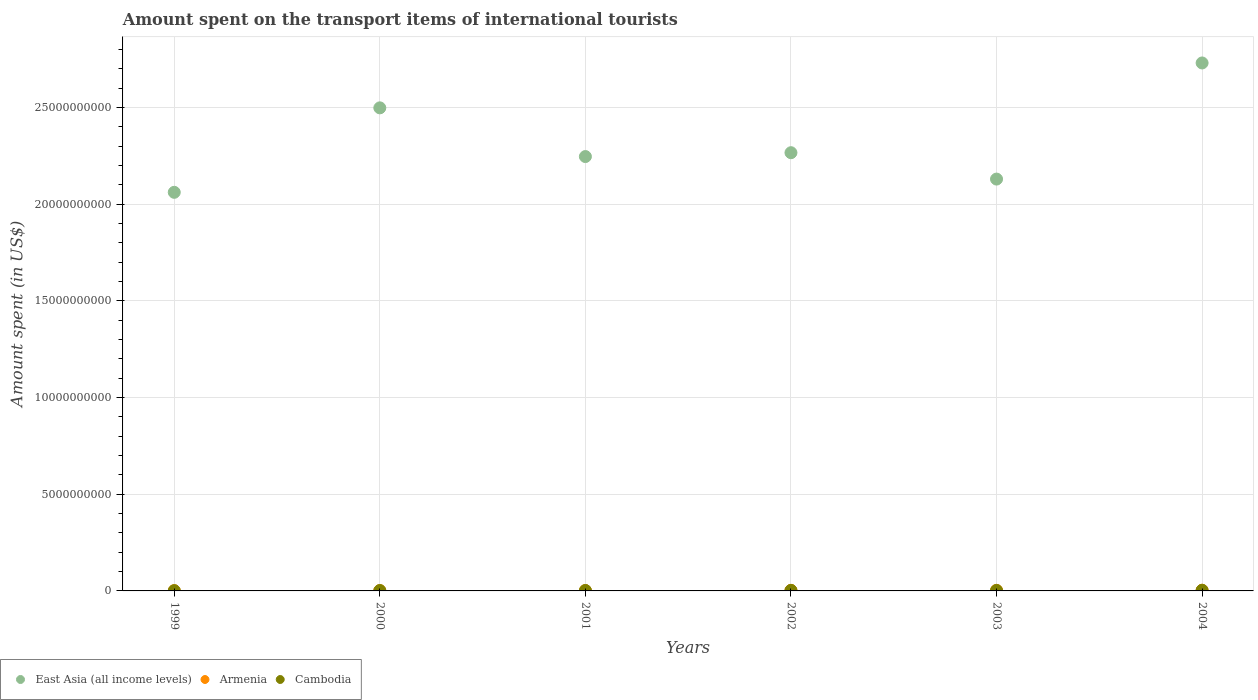Is the number of dotlines equal to the number of legend labels?
Offer a terse response. Yes. What is the amount spent on the transport items of international tourists in East Asia (all income levels) in 1999?
Offer a very short reply. 2.06e+1. Across all years, what is the maximum amount spent on the transport items of international tourists in Armenia?
Provide a succinct answer. 3.70e+07. Across all years, what is the minimum amount spent on the transport items of international tourists in East Asia (all income levels)?
Give a very brief answer. 2.06e+1. In which year was the amount spent on the transport items of international tourists in Cambodia maximum?
Provide a succinct answer. 2004. In which year was the amount spent on the transport items of international tourists in East Asia (all income levels) minimum?
Ensure brevity in your answer.  1999. What is the total amount spent on the transport items of international tourists in East Asia (all income levels) in the graph?
Your answer should be very brief. 1.39e+11. What is the difference between the amount spent on the transport items of international tourists in Cambodia in 1999 and that in 2002?
Offer a very short reply. -1.30e+07. What is the difference between the amount spent on the transport items of international tourists in Cambodia in 2002 and the amount spent on the transport items of international tourists in Armenia in 2000?
Your answer should be very brief. 1.00e+07. What is the average amount spent on the transport items of international tourists in East Asia (all income levels) per year?
Keep it short and to the point. 2.32e+1. In the year 2001, what is the difference between the amount spent on the transport items of international tourists in Cambodia and amount spent on the transport items of international tourists in East Asia (all income levels)?
Give a very brief answer. -2.24e+1. In how many years, is the amount spent on the transport items of international tourists in Cambodia greater than 19000000000 US$?
Your answer should be compact. 0. What is the ratio of the amount spent on the transport items of international tourists in East Asia (all income levels) in 2000 to that in 2001?
Make the answer very short. 1.11. Is the difference between the amount spent on the transport items of international tourists in Cambodia in 1999 and 2004 greater than the difference between the amount spent on the transport items of international tourists in East Asia (all income levels) in 1999 and 2004?
Your answer should be compact. Yes. What is the difference between the highest and the lowest amount spent on the transport items of international tourists in Cambodia?
Make the answer very short. 1.90e+07. In how many years, is the amount spent on the transport items of international tourists in Cambodia greater than the average amount spent on the transport items of international tourists in Cambodia taken over all years?
Your answer should be very brief. 3. Is the amount spent on the transport items of international tourists in Cambodia strictly less than the amount spent on the transport items of international tourists in East Asia (all income levels) over the years?
Provide a short and direct response. Yes. How many years are there in the graph?
Your response must be concise. 6. Are the values on the major ticks of Y-axis written in scientific E-notation?
Give a very brief answer. No. Does the graph contain any zero values?
Provide a short and direct response. No. How many legend labels are there?
Provide a short and direct response. 3. How are the legend labels stacked?
Give a very brief answer. Horizontal. What is the title of the graph?
Offer a very short reply. Amount spent on the transport items of international tourists. Does "Bosnia and Herzegovina" appear as one of the legend labels in the graph?
Give a very brief answer. No. What is the label or title of the X-axis?
Provide a short and direct response. Years. What is the label or title of the Y-axis?
Give a very brief answer. Amount spent (in US$). What is the Amount spent (in US$) of East Asia (all income levels) in 1999?
Keep it short and to the point. 2.06e+1. What is the Amount spent (in US$) of Armenia in 1999?
Your answer should be compact. 1.40e+07. What is the Amount spent (in US$) in Cambodia in 1999?
Offer a very short reply. 1.30e+07. What is the Amount spent (in US$) of East Asia (all income levels) in 2000?
Ensure brevity in your answer.  2.50e+1. What is the Amount spent (in US$) of Armenia in 2000?
Your answer should be compact. 1.60e+07. What is the Amount spent (in US$) in Cambodia in 2000?
Offer a terse response. 1.90e+07. What is the Amount spent (in US$) in East Asia (all income levels) in 2001?
Your answer should be compact. 2.25e+1. What is the Amount spent (in US$) in Armenia in 2001?
Keep it short and to the point. 1.90e+07. What is the Amount spent (in US$) of Cambodia in 2001?
Your response must be concise. 2.20e+07. What is the Amount spent (in US$) of East Asia (all income levels) in 2002?
Offer a terse response. 2.27e+1. What is the Amount spent (in US$) in Armenia in 2002?
Ensure brevity in your answer.  3.10e+07. What is the Amount spent (in US$) in Cambodia in 2002?
Offer a terse response. 2.60e+07. What is the Amount spent (in US$) in East Asia (all income levels) in 2003?
Provide a short and direct response. 2.13e+1. What is the Amount spent (in US$) in Armenia in 2003?
Offer a very short reply. 3.00e+07. What is the Amount spent (in US$) of Cambodia in 2003?
Your answer should be compact. 2.40e+07. What is the Amount spent (in US$) of East Asia (all income levels) in 2004?
Offer a very short reply. 2.73e+1. What is the Amount spent (in US$) in Armenia in 2004?
Make the answer very short. 3.70e+07. What is the Amount spent (in US$) of Cambodia in 2004?
Give a very brief answer. 3.20e+07. Across all years, what is the maximum Amount spent (in US$) of East Asia (all income levels)?
Keep it short and to the point. 2.73e+1. Across all years, what is the maximum Amount spent (in US$) in Armenia?
Your answer should be very brief. 3.70e+07. Across all years, what is the maximum Amount spent (in US$) of Cambodia?
Ensure brevity in your answer.  3.20e+07. Across all years, what is the minimum Amount spent (in US$) in East Asia (all income levels)?
Ensure brevity in your answer.  2.06e+1. Across all years, what is the minimum Amount spent (in US$) of Armenia?
Your answer should be compact. 1.40e+07. Across all years, what is the minimum Amount spent (in US$) of Cambodia?
Make the answer very short. 1.30e+07. What is the total Amount spent (in US$) of East Asia (all income levels) in the graph?
Give a very brief answer. 1.39e+11. What is the total Amount spent (in US$) in Armenia in the graph?
Offer a terse response. 1.47e+08. What is the total Amount spent (in US$) in Cambodia in the graph?
Ensure brevity in your answer.  1.36e+08. What is the difference between the Amount spent (in US$) of East Asia (all income levels) in 1999 and that in 2000?
Give a very brief answer. -4.37e+09. What is the difference between the Amount spent (in US$) of Cambodia in 1999 and that in 2000?
Keep it short and to the point. -6.00e+06. What is the difference between the Amount spent (in US$) of East Asia (all income levels) in 1999 and that in 2001?
Offer a very short reply. -1.85e+09. What is the difference between the Amount spent (in US$) in Armenia in 1999 and that in 2001?
Give a very brief answer. -5.00e+06. What is the difference between the Amount spent (in US$) in Cambodia in 1999 and that in 2001?
Provide a succinct answer. -9.00e+06. What is the difference between the Amount spent (in US$) of East Asia (all income levels) in 1999 and that in 2002?
Provide a succinct answer. -2.05e+09. What is the difference between the Amount spent (in US$) of Armenia in 1999 and that in 2002?
Your answer should be compact. -1.70e+07. What is the difference between the Amount spent (in US$) in Cambodia in 1999 and that in 2002?
Provide a short and direct response. -1.30e+07. What is the difference between the Amount spent (in US$) of East Asia (all income levels) in 1999 and that in 2003?
Ensure brevity in your answer.  -6.85e+08. What is the difference between the Amount spent (in US$) of Armenia in 1999 and that in 2003?
Your answer should be compact. -1.60e+07. What is the difference between the Amount spent (in US$) in Cambodia in 1999 and that in 2003?
Your answer should be compact. -1.10e+07. What is the difference between the Amount spent (in US$) in East Asia (all income levels) in 1999 and that in 2004?
Your response must be concise. -6.69e+09. What is the difference between the Amount spent (in US$) of Armenia in 1999 and that in 2004?
Your answer should be compact. -2.30e+07. What is the difference between the Amount spent (in US$) in Cambodia in 1999 and that in 2004?
Make the answer very short. -1.90e+07. What is the difference between the Amount spent (in US$) in East Asia (all income levels) in 2000 and that in 2001?
Ensure brevity in your answer.  2.52e+09. What is the difference between the Amount spent (in US$) in Armenia in 2000 and that in 2001?
Your answer should be very brief. -3.00e+06. What is the difference between the Amount spent (in US$) in East Asia (all income levels) in 2000 and that in 2002?
Offer a very short reply. 2.32e+09. What is the difference between the Amount spent (in US$) of Armenia in 2000 and that in 2002?
Offer a very short reply. -1.50e+07. What is the difference between the Amount spent (in US$) in Cambodia in 2000 and that in 2002?
Your answer should be very brief. -7.00e+06. What is the difference between the Amount spent (in US$) of East Asia (all income levels) in 2000 and that in 2003?
Give a very brief answer. 3.68e+09. What is the difference between the Amount spent (in US$) of Armenia in 2000 and that in 2003?
Your response must be concise. -1.40e+07. What is the difference between the Amount spent (in US$) in Cambodia in 2000 and that in 2003?
Make the answer very short. -5.00e+06. What is the difference between the Amount spent (in US$) in East Asia (all income levels) in 2000 and that in 2004?
Make the answer very short. -2.32e+09. What is the difference between the Amount spent (in US$) in Armenia in 2000 and that in 2004?
Offer a terse response. -2.10e+07. What is the difference between the Amount spent (in US$) of Cambodia in 2000 and that in 2004?
Offer a very short reply. -1.30e+07. What is the difference between the Amount spent (in US$) in East Asia (all income levels) in 2001 and that in 2002?
Make the answer very short. -2.00e+08. What is the difference between the Amount spent (in US$) of Armenia in 2001 and that in 2002?
Offer a very short reply. -1.20e+07. What is the difference between the Amount spent (in US$) in East Asia (all income levels) in 2001 and that in 2003?
Provide a succinct answer. 1.16e+09. What is the difference between the Amount spent (in US$) in Armenia in 2001 and that in 2003?
Ensure brevity in your answer.  -1.10e+07. What is the difference between the Amount spent (in US$) of Cambodia in 2001 and that in 2003?
Ensure brevity in your answer.  -2.00e+06. What is the difference between the Amount spent (in US$) of East Asia (all income levels) in 2001 and that in 2004?
Keep it short and to the point. -4.84e+09. What is the difference between the Amount spent (in US$) in Armenia in 2001 and that in 2004?
Your response must be concise. -1.80e+07. What is the difference between the Amount spent (in US$) in Cambodia in 2001 and that in 2004?
Make the answer very short. -1.00e+07. What is the difference between the Amount spent (in US$) in East Asia (all income levels) in 2002 and that in 2003?
Provide a short and direct response. 1.36e+09. What is the difference between the Amount spent (in US$) of Armenia in 2002 and that in 2003?
Keep it short and to the point. 1.00e+06. What is the difference between the Amount spent (in US$) of East Asia (all income levels) in 2002 and that in 2004?
Provide a succinct answer. -4.64e+09. What is the difference between the Amount spent (in US$) in Armenia in 2002 and that in 2004?
Provide a succinct answer. -6.00e+06. What is the difference between the Amount spent (in US$) in Cambodia in 2002 and that in 2004?
Provide a succinct answer. -6.00e+06. What is the difference between the Amount spent (in US$) in East Asia (all income levels) in 2003 and that in 2004?
Make the answer very short. -6.01e+09. What is the difference between the Amount spent (in US$) in Armenia in 2003 and that in 2004?
Give a very brief answer. -7.00e+06. What is the difference between the Amount spent (in US$) of Cambodia in 2003 and that in 2004?
Offer a terse response. -8.00e+06. What is the difference between the Amount spent (in US$) in East Asia (all income levels) in 1999 and the Amount spent (in US$) in Armenia in 2000?
Provide a succinct answer. 2.06e+1. What is the difference between the Amount spent (in US$) in East Asia (all income levels) in 1999 and the Amount spent (in US$) in Cambodia in 2000?
Make the answer very short. 2.06e+1. What is the difference between the Amount spent (in US$) in Armenia in 1999 and the Amount spent (in US$) in Cambodia in 2000?
Keep it short and to the point. -5.00e+06. What is the difference between the Amount spent (in US$) in East Asia (all income levels) in 1999 and the Amount spent (in US$) in Armenia in 2001?
Keep it short and to the point. 2.06e+1. What is the difference between the Amount spent (in US$) in East Asia (all income levels) in 1999 and the Amount spent (in US$) in Cambodia in 2001?
Keep it short and to the point. 2.06e+1. What is the difference between the Amount spent (in US$) in Armenia in 1999 and the Amount spent (in US$) in Cambodia in 2001?
Offer a very short reply. -8.00e+06. What is the difference between the Amount spent (in US$) of East Asia (all income levels) in 1999 and the Amount spent (in US$) of Armenia in 2002?
Make the answer very short. 2.06e+1. What is the difference between the Amount spent (in US$) in East Asia (all income levels) in 1999 and the Amount spent (in US$) in Cambodia in 2002?
Keep it short and to the point. 2.06e+1. What is the difference between the Amount spent (in US$) in Armenia in 1999 and the Amount spent (in US$) in Cambodia in 2002?
Ensure brevity in your answer.  -1.20e+07. What is the difference between the Amount spent (in US$) in East Asia (all income levels) in 1999 and the Amount spent (in US$) in Armenia in 2003?
Keep it short and to the point. 2.06e+1. What is the difference between the Amount spent (in US$) of East Asia (all income levels) in 1999 and the Amount spent (in US$) of Cambodia in 2003?
Your response must be concise. 2.06e+1. What is the difference between the Amount spent (in US$) of Armenia in 1999 and the Amount spent (in US$) of Cambodia in 2003?
Give a very brief answer. -1.00e+07. What is the difference between the Amount spent (in US$) of East Asia (all income levels) in 1999 and the Amount spent (in US$) of Armenia in 2004?
Your response must be concise. 2.06e+1. What is the difference between the Amount spent (in US$) of East Asia (all income levels) in 1999 and the Amount spent (in US$) of Cambodia in 2004?
Provide a succinct answer. 2.06e+1. What is the difference between the Amount spent (in US$) of Armenia in 1999 and the Amount spent (in US$) of Cambodia in 2004?
Provide a short and direct response. -1.80e+07. What is the difference between the Amount spent (in US$) of East Asia (all income levels) in 2000 and the Amount spent (in US$) of Armenia in 2001?
Provide a succinct answer. 2.50e+1. What is the difference between the Amount spent (in US$) in East Asia (all income levels) in 2000 and the Amount spent (in US$) in Cambodia in 2001?
Make the answer very short. 2.50e+1. What is the difference between the Amount spent (in US$) of Armenia in 2000 and the Amount spent (in US$) of Cambodia in 2001?
Ensure brevity in your answer.  -6.00e+06. What is the difference between the Amount spent (in US$) in East Asia (all income levels) in 2000 and the Amount spent (in US$) in Armenia in 2002?
Offer a terse response. 2.50e+1. What is the difference between the Amount spent (in US$) of East Asia (all income levels) in 2000 and the Amount spent (in US$) of Cambodia in 2002?
Your answer should be very brief. 2.50e+1. What is the difference between the Amount spent (in US$) in Armenia in 2000 and the Amount spent (in US$) in Cambodia in 2002?
Offer a terse response. -1.00e+07. What is the difference between the Amount spent (in US$) of East Asia (all income levels) in 2000 and the Amount spent (in US$) of Armenia in 2003?
Offer a very short reply. 2.50e+1. What is the difference between the Amount spent (in US$) in East Asia (all income levels) in 2000 and the Amount spent (in US$) in Cambodia in 2003?
Make the answer very short. 2.50e+1. What is the difference between the Amount spent (in US$) of Armenia in 2000 and the Amount spent (in US$) of Cambodia in 2003?
Your answer should be very brief. -8.00e+06. What is the difference between the Amount spent (in US$) of East Asia (all income levels) in 2000 and the Amount spent (in US$) of Armenia in 2004?
Your response must be concise. 2.49e+1. What is the difference between the Amount spent (in US$) of East Asia (all income levels) in 2000 and the Amount spent (in US$) of Cambodia in 2004?
Provide a short and direct response. 2.50e+1. What is the difference between the Amount spent (in US$) of Armenia in 2000 and the Amount spent (in US$) of Cambodia in 2004?
Your answer should be very brief. -1.60e+07. What is the difference between the Amount spent (in US$) in East Asia (all income levels) in 2001 and the Amount spent (in US$) in Armenia in 2002?
Offer a very short reply. 2.24e+1. What is the difference between the Amount spent (in US$) of East Asia (all income levels) in 2001 and the Amount spent (in US$) of Cambodia in 2002?
Ensure brevity in your answer.  2.24e+1. What is the difference between the Amount spent (in US$) in Armenia in 2001 and the Amount spent (in US$) in Cambodia in 2002?
Provide a succinct answer. -7.00e+06. What is the difference between the Amount spent (in US$) in East Asia (all income levels) in 2001 and the Amount spent (in US$) in Armenia in 2003?
Keep it short and to the point. 2.24e+1. What is the difference between the Amount spent (in US$) in East Asia (all income levels) in 2001 and the Amount spent (in US$) in Cambodia in 2003?
Your answer should be compact. 2.24e+1. What is the difference between the Amount spent (in US$) of Armenia in 2001 and the Amount spent (in US$) of Cambodia in 2003?
Offer a very short reply. -5.00e+06. What is the difference between the Amount spent (in US$) in East Asia (all income levels) in 2001 and the Amount spent (in US$) in Armenia in 2004?
Your answer should be compact. 2.24e+1. What is the difference between the Amount spent (in US$) in East Asia (all income levels) in 2001 and the Amount spent (in US$) in Cambodia in 2004?
Give a very brief answer. 2.24e+1. What is the difference between the Amount spent (in US$) in Armenia in 2001 and the Amount spent (in US$) in Cambodia in 2004?
Ensure brevity in your answer.  -1.30e+07. What is the difference between the Amount spent (in US$) in East Asia (all income levels) in 2002 and the Amount spent (in US$) in Armenia in 2003?
Offer a terse response. 2.26e+1. What is the difference between the Amount spent (in US$) of East Asia (all income levels) in 2002 and the Amount spent (in US$) of Cambodia in 2003?
Offer a terse response. 2.26e+1. What is the difference between the Amount spent (in US$) of Armenia in 2002 and the Amount spent (in US$) of Cambodia in 2003?
Give a very brief answer. 7.00e+06. What is the difference between the Amount spent (in US$) of East Asia (all income levels) in 2002 and the Amount spent (in US$) of Armenia in 2004?
Your answer should be very brief. 2.26e+1. What is the difference between the Amount spent (in US$) of East Asia (all income levels) in 2002 and the Amount spent (in US$) of Cambodia in 2004?
Ensure brevity in your answer.  2.26e+1. What is the difference between the Amount spent (in US$) of Armenia in 2002 and the Amount spent (in US$) of Cambodia in 2004?
Offer a very short reply. -1.00e+06. What is the difference between the Amount spent (in US$) in East Asia (all income levels) in 2003 and the Amount spent (in US$) in Armenia in 2004?
Offer a terse response. 2.13e+1. What is the difference between the Amount spent (in US$) in East Asia (all income levels) in 2003 and the Amount spent (in US$) in Cambodia in 2004?
Make the answer very short. 2.13e+1. What is the average Amount spent (in US$) in East Asia (all income levels) per year?
Provide a succinct answer. 2.32e+1. What is the average Amount spent (in US$) in Armenia per year?
Your answer should be very brief. 2.45e+07. What is the average Amount spent (in US$) of Cambodia per year?
Provide a succinct answer. 2.27e+07. In the year 1999, what is the difference between the Amount spent (in US$) of East Asia (all income levels) and Amount spent (in US$) of Armenia?
Offer a very short reply. 2.06e+1. In the year 1999, what is the difference between the Amount spent (in US$) of East Asia (all income levels) and Amount spent (in US$) of Cambodia?
Your response must be concise. 2.06e+1. In the year 1999, what is the difference between the Amount spent (in US$) of Armenia and Amount spent (in US$) of Cambodia?
Your answer should be compact. 1.00e+06. In the year 2000, what is the difference between the Amount spent (in US$) in East Asia (all income levels) and Amount spent (in US$) in Armenia?
Keep it short and to the point. 2.50e+1. In the year 2000, what is the difference between the Amount spent (in US$) in East Asia (all income levels) and Amount spent (in US$) in Cambodia?
Your response must be concise. 2.50e+1. In the year 2001, what is the difference between the Amount spent (in US$) in East Asia (all income levels) and Amount spent (in US$) in Armenia?
Ensure brevity in your answer.  2.24e+1. In the year 2001, what is the difference between the Amount spent (in US$) in East Asia (all income levels) and Amount spent (in US$) in Cambodia?
Your response must be concise. 2.24e+1. In the year 2002, what is the difference between the Amount spent (in US$) in East Asia (all income levels) and Amount spent (in US$) in Armenia?
Ensure brevity in your answer.  2.26e+1. In the year 2002, what is the difference between the Amount spent (in US$) in East Asia (all income levels) and Amount spent (in US$) in Cambodia?
Keep it short and to the point. 2.26e+1. In the year 2002, what is the difference between the Amount spent (in US$) in Armenia and Amount spent (in US$) in Cambodia?
Offer a terse response. 5.00e+06. In the year 2003, what is the difference between the Amount spent (in US$) in East Asia (all income levels) and Amount spent (in US$) in Armenia?
Make the answer very short. 2.13e+1. In the year 2003, what is the difference between the Amount spent (in US$) of East Asia (all income levels) and Amount spent (in US$) of Cambodia?
Give a very brief answer. 2.13e+1. In the year 2003, what is the difference between the Amount spent (in US$) in Armenia and Amount spent (in US$) in Cambodia?
Make the answer very short. 6.00e+06. In the year 2004, what is the difference between the Amount spent (in US$) of East Asia (all income levels) and Amount spent (in US$) of Armenia?
Your answer should be compact. 2.73e+1. In the year 2004, what is the difference between the Amount spent (in US$) in East Asia (all income levels) and Amount spent (in US$) in Cambodia?
Make the answer very short. 2.73e+1. What is the ratio of the Amount spent (in US$) of East Asia (all income levels) in 1999 to that in 2000?
Your answer should be very brief. 0.83. What is the ratio of the Amount spent (in US$) of Cambodia in 1999 to that in 2000?
Ensure brevity in your answer.  0.68. What is the ratio of the Amount spent (in US$) of East Asia (all income levels) in 1999 to that in 2001?
Your answer should be compact. 0.92. What is the ratio of the Amount spent (in US$) of Armenia in 1999 to that in 2001?
Make the answer very short. 0.74. What is the ratio of the Amount spent (in US$) in Cambodia in 1999 to that in 2001?
Ensure brevity in your answer.  0.59. What is the ratio of the Amount spent (in US$) of East Asia (all income levels) in 1999 to that in 2002?
Offer a very short reply. 0.91. What is the ratio of the Amount spent (in US$) in Armenia in 1999 to that in 2002?
Your answer should be very brief. 0.45. What is the ratio of the Amount spent (in US$) in East Asia (all income levels) in 1999 to that in 2003?
Offer a terse response. 0.97. What is the ratio of the Amount spent (in US$) of Armenia in 1999 to that in 2003?
Ensure brevity in your answer.  0.47. What is the ratio of the Amount spent (in US$) in Cambodia in 1999 to that in 2003?
Your response must be concise. 0.54. What is the ratio of the Amount spent (in US$) in East Asia (all income levels) in 1999 to that in 2004?
Give a very brief answer. 0.76. What is the ratio of the Amount spent (in US$) in Armenia in 1999 to that in 2004?
Your answer should be compact. 0.38. What is the ratio of the Amount spent (in US$) of Cambodia in 1999 to that in 2004?
Offer a very short reply. 0.41. What is the ratio of the Amount spent (in US$) in East Asia (all income levels) in 2000 to that in 2001?
Provide a succinct answer. 1.11. What is the ratio of the Amount spent (in US$) in Armenia in 2000 to that in 2001?
Your answer should be very brief. 0.84. What is the ratio of the Amount spent (in US$) of Cambodia in 2000 to that in 2001?
Keep it short and to the point. 0.86. What is the ratio of the Amount spent (in US$) of East Asia (all income levels) in 2000 to that in 2002?
Provide a short and direct response. 1.1. What is the ratio of the Amount spent (in US$) in Armenia in 2000 to that in 2002?
Provide a short and direct response. 0.52. What is the ratio of the Amount spent (in US$) in Cambodia in 2000 to that in 2002?
Provide a succinct answer. 0.73. What is the ratio of the Amount spent (in US$) of East Asia (all income levels) in 2000 to that in 2003?
Offer a terse response. 1.17. What is the ratio of the Amount spent (in US$) of Armenia in 2000 to that in 2003?
Offer a very short reply. 0.53. What is the ratio of the Amount spent (in US$) of Cambodia in 2000 to that in 2003?
Your answer should be compact. 0.79. What is the ratio of the Amount spent (in US$) of East Asia (all income levels) in 2000 to that in 2004?
Provide a short and direct response. 0.92. What is the ratio of the Amount spent (in US$) of Armenia in 2000 to that in 2004?
Make the answer very short. 0.43. What is the ratio of the Amount spent (in US$) in Cambodia in 2000 to that in 2004?
Offer a terse response. 0.59. What is the ratio of the Amount spent (in US$) of East Asia (all income levels) in 2001 to that in 2002?
Give a very brief answer. 0.99. What is the ratio of the Amount spent (in US$) of Armenia in 2001 to that in 2002?
Your response must be concise. 0.61. What is the ratio of the Amount spent (in US$) in Cambodia in 2001 to that in 2002?
Ensure brevity in your answer.  0.85. What is the ratio of the Amount spent (in US$) of East Asia (all income levels) in 2001 to that in 2003?
Make the answer very short. 1.05. What is the ratio of the Amount spent (in US$) of Armenia in 2001 to that in 2003?
Your answer should be compact. 0.63. What is the ratio of the Amount spent (in US$) in Cambodia in 2001 to that in 2003?
Make the answer very short. 0.92. What is the ratio of the Amount spent (in US$) in East Asia (all income levels) in 2001 to that in 2004?
Offer a terse response. 0.82. What is the ratio of the Amount spent (in US$) of Armenia in 2001 to that in 2004?
Your answer should be very brief. 0.51. What is the ratio of the Amount spent (in US$) of Cambodia in 2001 to that in 2004?
Your response must be concise. 0.69. What is the ratio of the Amount spent (in US$) of East Asia (all income levels) in 2002 to that in 2003?
Keep it short and to the point. 1.06. What is the ratio of the Amount spent (in US$) in Armenia in 2002 to that in 2003?
Offer a very short reply. 1.03. What is the ratio of the Amount spent (in US$) of Cambodia in 2002 to that in 2003?
Keep it short and to the point. 1.08. What is the ratio of the Amount spent (in US$) in East Asia (all income levels) in 2002 to that in 2004?
Offer a terse response. 0.83. What is the ratio of the Amount spent (in US$) of Armenia in 2002 to that in 2004?
Ensure brevity in your answer.  0.84. What is the ratio of the Amount spent (in US$) in Cambodia in 2002 to that in 2004?
Your answer should be very brief. 0.81. What is the ratio of the Amount spent (in US$) of East Asia (all income levels) in 2003 to that in 2004?
Keep it short and to the point. 0.78. What is the ratio of the Amount spent (in US$) in Armenia in 2003 to that in 2004?
Your response must be concise. 0.81. What is the difference between the highest and the second highest Amount spent (in US$) in East Asia (all income levels)?
Provide a short and direct response. 2.32e+09. What is the difference between the highest and the second highest Amount spent (in US$) of Armenia?
Keep it short and to the point. 6.00e+06. What is the difference between the highest and the second highest Amount spent (in US$) in Cambodia?
Provide a short and direct response. 6.00e+06. What is the difference between the highest and the lowest Amount spent (in US$) in East Asia (all income levels)?
Your answer should be compact. 6.69e+09. What is the difference between the highest and the lowest Amount spent (in US$) in Armenia?
Your answer should be very brief. 2.30e+07. What is the difference between the highest and the lowest Amount spent (in US$) of Cambodia?
Provide a short and direct response. 1.90e+07. 